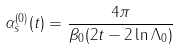<formula> <loc_0><loc_0><loc_500><loc_500>\alpha ^ { ( 0 ) } _ { s } ( t ) = \frac { 4 \pi } { \beta _ { 0 } ( 2 t - 2 \ln \Lambda _ { 0 } ) }</formula> 